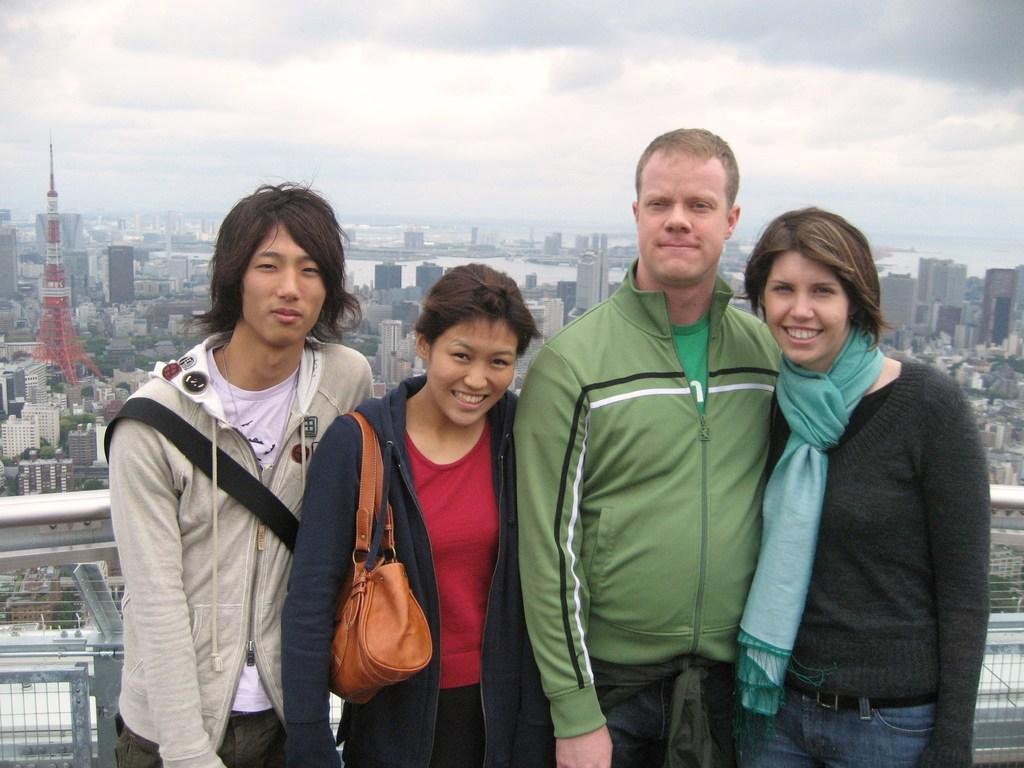Can you describe this image briefly? In this image we can see a group of four people. There are many trees in the image. There is a sea in the image. There are many buildings and skyscrapers in the image. There is a fence in the image. There is a sky in the image. 